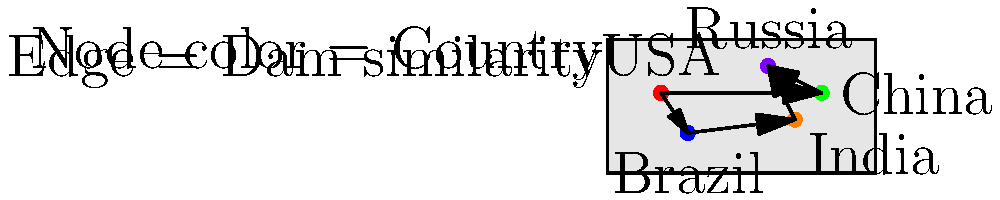Based on the node-link diagram overlaid on a world map, which country has the most connections (edges) to other countries in terms of dam similarity, and what does this suggest about its role in the global dam landscape? To answer this question, we need to analyze the node-link diagram:

1. Identify the countries (nodes) in the diagram:
   - USA (red)
   - Brazil (blue)
   - China (green)
   - India (orange)
   - Russia (purple)

2. Count the number of connections (edges) for each country:
   - USA: 2 connections (to Brazil and China)
   - Brazil: 2 connections (to USA and India)
   - China: 2 connections (to USA and Russia)
   - India: 2 connections (to Brazil and Russia)
   - Russia: 2 connections (to China and India)

3. Determine the country with the most connections:
   All countries have an equal number of connections (2 each).

4. Interpret the results:
   Since all countries have the same number of connections, there is no single country that stands out as having the most similarities in terms of dams. This suggests a balanced global dam landscape where each country has unique characteristics that are similar to two other countries in the network.

5. Consider the implications:
   This balanced network implies that dam knowledge and technology might be well-distributed among these major countries, with each potentially serving as a hub for different aspects of dam engineering or management.
Answer: No single country; all have equal connections, suggesting a balanced global dam landscape. 